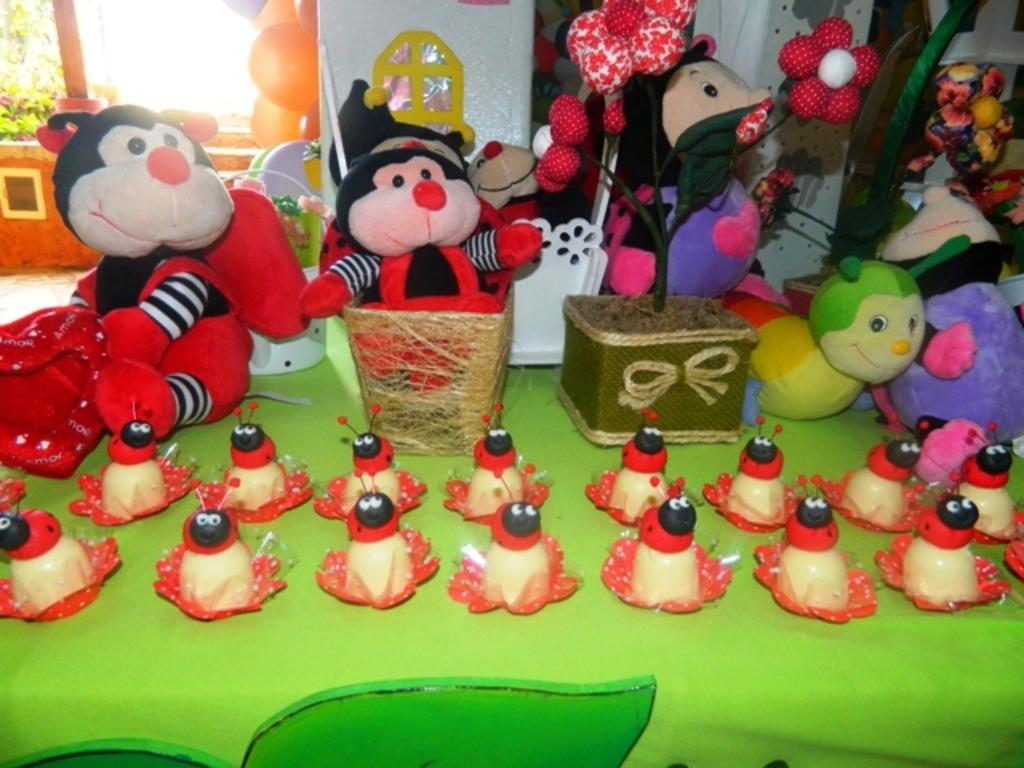What objects are on the table in the image? There are toys on the table in the image. What can be seen in the background of the image? There are balloons and plants in the background of the image. What type of holiday is being celebrated on the island in the image? There is no island or holiday present in the image; it features toys on a table and balloons and plants in the background. 